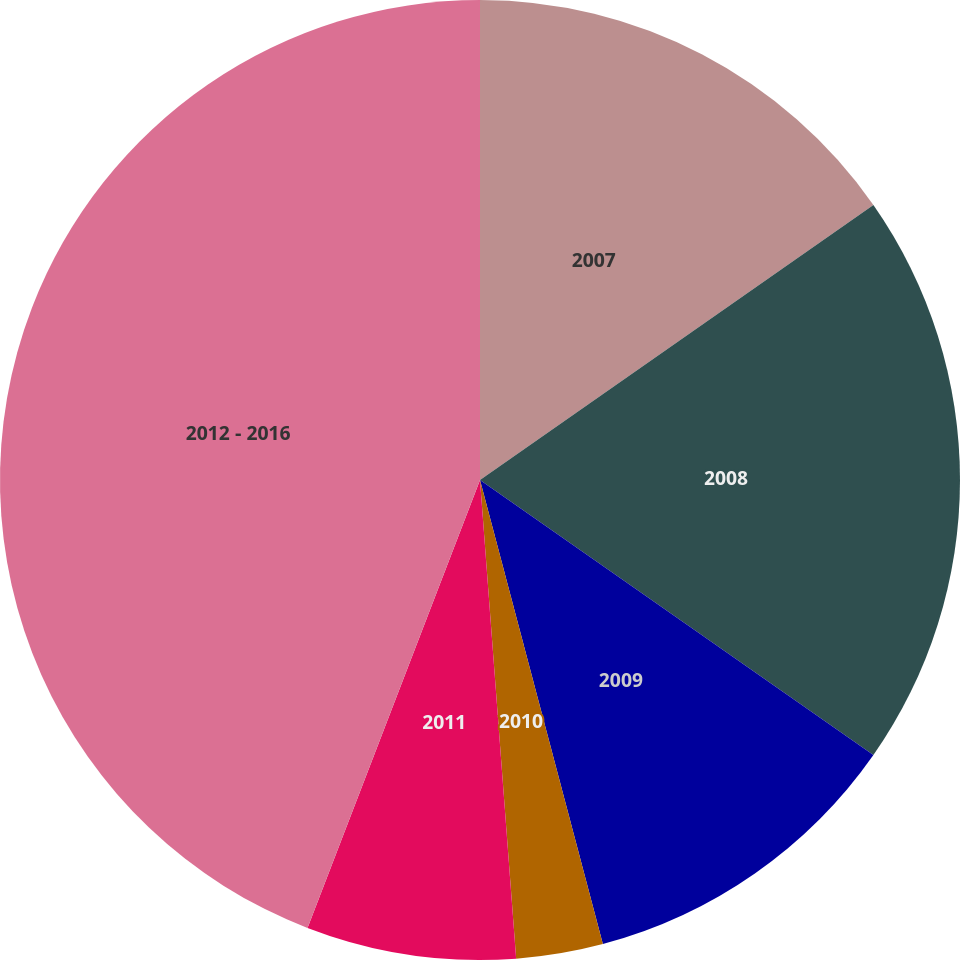<chart> <loc_0><loc_0><loc_500><loc_500><pie_chart><fcel>2007<fcel>2008<fcel>2009<fcel>2010<fcel>2011<fcel>2012 - 2016<nl><fcel>15.29%<fcel>19.42%<fcel>11.17%<fcel>2.92%<fcel>7.05%<fcel>44.15%<nl></chart> 